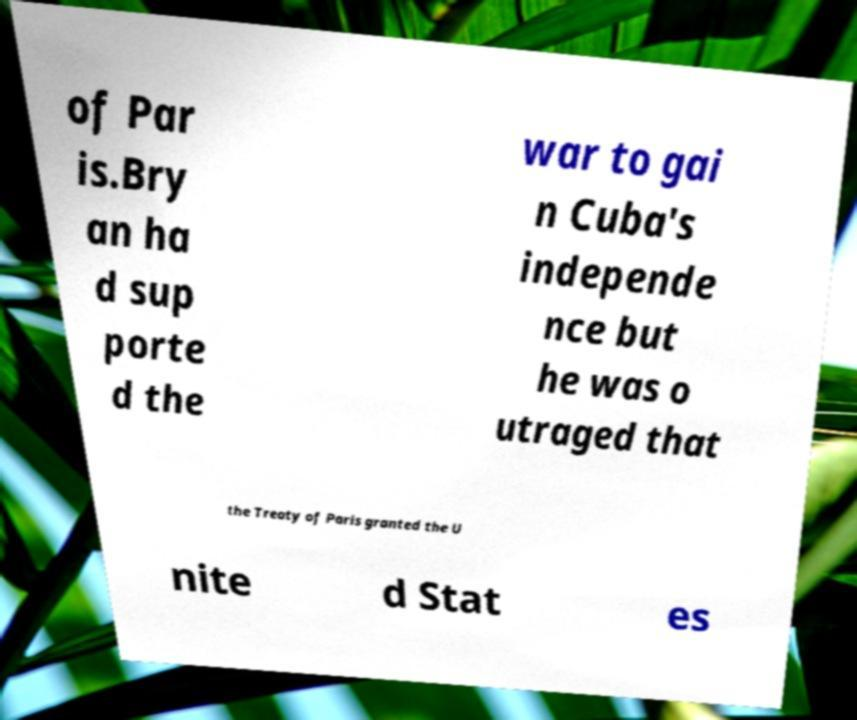Can you read and provide the text displayed in the image?This photo seems to have some interesting text. Can you extract and type it out for me? of Par is.Bry an ha d sup porte d the war to gai n Cuba's independe nce but he was o utraged that the Treaty of Paris granted the U nite d Stat es 